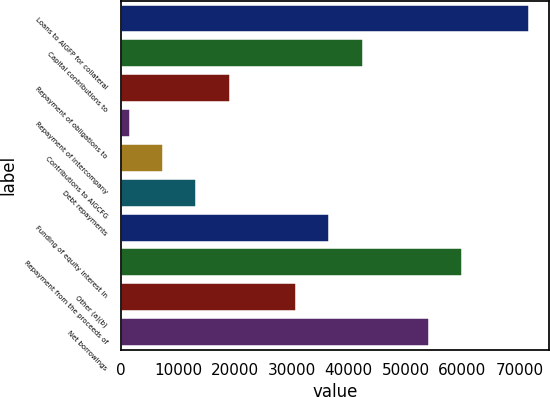<chart> <loc_0><loc_0><loc_500><loc_500><bar_chart><fcel>Loans to AIGFP for collateral<fcel>Capital contributions to<fcel>Repayment of obligations to<fcel>Repayment of intercompany<fcel>Contributions to AIGCFG<fcel>Debt repayments<fcel>Funding of equity interest in<fcel>Repayment from the proceeds of<fcel>Other (a)(b)<fcel>Net borrowings<nl><fcel>71694.4<fcel>42458.4<fcel>19069.6<fcel>1528<fcel>7375.2<fcel>13222.4<fcel>36611.2<fcel>60000<fcel>30764<fcel>54152.8<nl></chart> 